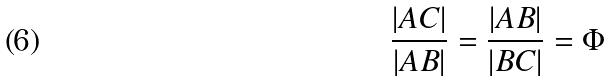<formula> <loc_0><loc_0><loc_500><loc_500>\frac { | A C | } { | A B | } = \frac { | A B | } { | B C | } = \Phi</formula> 